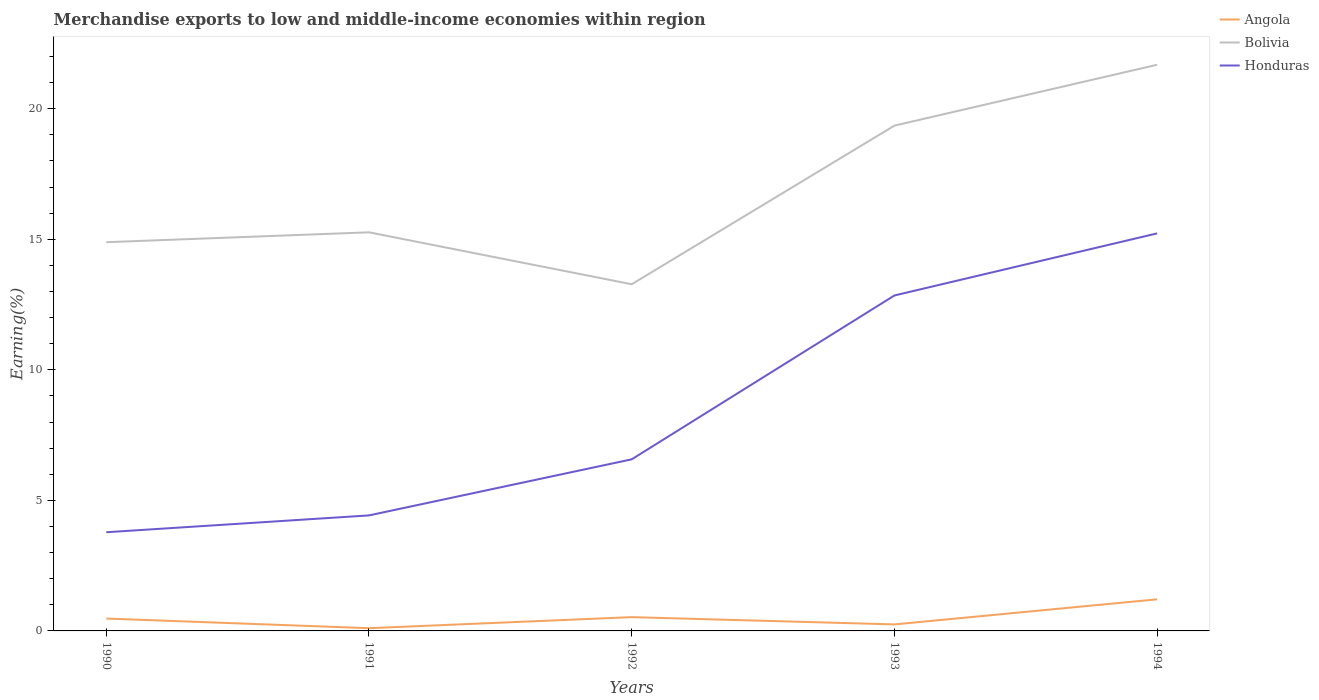Across all years, what is the maximum percentage of amount earned from merchandise exports in Honduras?
Provide a succinct answer. 3.78. In which year was the percentage of amount earned from merchandise exports in Honduras maximum?
Your answer should be compact. 1990. What is the total percentage of amount earned from merchandise exports in Angola in the graph?
Give a very brief answer. -0.14. What is the difference between the highest and the second highest percentage of amount earned from merchandise exports in Angola?
Ensure brevity in your answer.  1.11. What is the difference between the highest and the lowest percentage of amount earned from merchandise exports in Angola?
Make the answer very short. 2. How many lines are there?
Offer a very short reply. 3. Are the values on the major ticks of Y-axis written in scientific E-notation?
Ensure brevity in your answer.  No. Where does the legend appear in the graph?
Provide a short and direct response. Top right. What is the title of the graph?
Your answer should be compact. Merchandise exports to low and middle-income economies within region. What is the label or title of the X-axis?
Your answer should be compact. Years. What is the label or title of the Y-axis?
Keep it short and to the point. Earning(%). What is the Earning(%) in Angola in 1990?
Your answer should be very brief. 0.47. What is the Earning(%) in Bolivia in 1990?
Offer a very short reply. 14.89. What is the Earning(%) of Honduras in 1990?
Your answer should be compact. 3.78. What is the Earning(%) in Angola in 1991?
Your answer should be very brief. 0.1. What is the Earning(%) in Bolivia in 1991?
Your answer should be compact. 15.26. What is the Earning(%) in Honduras in 1991?
Provide a short and direct response. 4.42. What is the Earning(%) of Angola in 1992?
Give a very brief answer. 0.53. What is the Earning(%) in Bolivia in 1992?
Make the answer very short. 13.28. What is the Earning(%) of Honduras in 1992?
Keep it short and to the point. 6.57. What is the Earning(%) in Angola in 1993?
Your answer should be compact. 0.25. What is the Earning(%) of Bolivia in 1993?
Keep it short and to the point. 19.35. What is the Earning(%) in Honduras in 1993?
Your answer should be compact. 12.85. What is the Earning(%) of Angola in 1994?
Keep it short and to the point. 1.21. What is the Earning(%) in Bolivia in 1994?
Make the answer very short. 21.68. What is the Earning(%) in Honduras in 1994?
Ensure brevity in your answer.  15.22. Across all years, what is the maximum Earning(%) in Angola?
Make the answer very short. 1.21. Across all years, what is the maximum Earning(%) of Bolivia?
Your answer should be compact. 21.68. Across all years, what is the maximum Earning(%) in Honduras?
Your answer should be compact. 15.22. Across all years, what is the minimum Earning(%) of Angola?
Give a very brief answer. 0.1. Across all years, what is the minimum Earning(%) in Bolivia?
Keep it short and to the point. 13.28. Across all years, what is the minimum Earning(%) of Honduras?
Ensure brevity in your answer.  3.78. What is the total Earning(%) of Angola in the graph?
Give a very brief answer. 2.57. What is the total Earning(%) in Bolivia in the graph?
Ensure brevity in your answer.  84.46. What is the total Earning(%) in Honduras in the graph?
Give a very brief answer. 42.84. What is the difference between the Earning(%) in Angola in 1990 and that in 1991?
Give a very brief answer. 0.37. What is the difference between the Earning(%) in Bolivia in 1990 and that in 1991?
Offer a very short reply. -0.38. What is the difference between the Earning(%) of Honduras in 1990 and that in 1991?
Give a very brief answer. -0.64. What is the difference between the Earning(%) of Angola in 1990 and that in 1992?
Provide a short and direct response. -0.05. What is the difference between the Earning(%) in Bolivia in 1990 and that in 1992?
Make the answer very short. 1.61. What is the difference between the Earning(%) of Honduras in 1990 and that in 1992?
Give a very brief answer. -2.79. What is the difference between the Earning(%) in Angola in 1990 and that in 1993?
Your answer should be very brief. 0.22. What is the difference between the Earning(%) of Bolivia in 1990 and that in 1993?
Offer a terse response. -4.46. What is the difference between the Earning(%) of Honduras in 1990 and that in 1993?
Provide a succinct answer. -9.07. What is the difference between the Earning(%) of Angola in 1990 and that in 1994?
Offer a very short reply. -0.74. What is the difference between the Earning(%) of Bolivia in 1990 and that in 1994?
Make the answer very short. -6.8. What is the difference between the Earning(%) of Honduras in 1990 and that in 1994?
Offer a terse response. -11.45. What is the difference between the Earning(%) in Angola in 1991 and that in 1992?
Your answer should be compact. -0.42. What is the difference between the Earning(%) of Bolivia in 1991 and that in 1992?
Ensure brevity in your answer.  1.99. What is the difference between the Earning(%) in Honduras in 1991 and that in 1992?
Provide a succinct answer. -2.15. What is the difference between the Earning(%) in Angola in 1991 and that in 1993?
Provide a succinct answer. -0.14. What is the difference between the Earning(%) of Bolivia in 1991 and that in 1993?
Keep it short and to the point. -4.09. What is the difference between the Earning(%) in Honduras in 1991 and that in 1993?
Offer a terse response. -8.42. What is the difference between the Earning(%) of Angola in 1991 and that in 1994?
Your answer should be very brief. -1.11. What is the difference between the Earning(%) of Bolivia in 1991 and that in 1994?
Your answer should be compact. -6.42. What is the difference between the Earning(%) in Honduras in 1991 and that in 1994?
Your answer should be compact. -10.8. What is the difference between the Earning(%) of Angola in 1992 and that in 1993?
Keep it short and to the point. 0.28. What is the difference between the Earning(%) in Bolivia in 1992 and that in 1993?
Keep it short and to the point. -6.07. What is the difference between the Earning(%) of Honduras in 1992 and that in 1993?
Offer a very short reply. -6.28. What is the difference between the Earning(%) in Angola in 1992 and that in 1994?
Keep it short and to the point. -0.68. What is the difference between the Earning(%) of Bolivia in 1992 and that in 1994?
Your answer should be compact. -8.41. What is the difference between the Earning(%) of Honduras in 1992 and that in 1994?
Give a very brief answer. -8.65. What is the difference between the Earning(%) in Angola in 1993 and that in 1994?
Keep it short and to the point. -0.96. What is the difference between the Earning(%) of Bolivia in 1993 and that in 1994?
Offer a very short reply. -2.33. What is the difference between the Earning(%) of Honduras in 1993 and that in 1994?
Ensure brevity in your answer.  -2.38. What is the difference between the Earning(%) in Angola in 1990 and the Earning(%) in Bolivia in 1991?
Keep it short and to the point. -14.79. What is the difference between the Earning(%) in Angola in 1990 and the Earning(%) in Honduras in 1991?
Ensure brevity in your answer.  -3.95. What is the difference between the Earning(%) in Bolivia in 1990 and the Earning(%) in Honduras in 1991?
Make the answer very short. 10.46. What is the difference between the Earning(%) in Angola in 1990 and the Earning(%) in Bolivia in 1992?
Give a very brief answer. -12.8. What is the difference between the Earning(%) in Angola in 1990 and the Earning(%) in Honduras in 1992?
Give a very brief answer. -6.1. What is the difference between the Earning(%) of Bolivia in 1990 and the Earning(%) of Honduras in 1992?
Your response must be concise. 8.32. What is the difference between the Earning(%) in Angola in 1990 and the Earning(%) in Bolivia in 1993?
Give a very brief answer. -18.88. What is the difference between the Earning(%) of Angola in 1990 and the Earning(%) of Honduras in 1993?
Offer a very short reply. -12.37. What is the difference between the Earning(%) of Bolivia in 1990 and the Earning(%) of Honduras in 1993?
Your response must be concise. 2.04. What is the difference between the Earning(%) in Angola in 1990 and the Earning(%) in Bolivia in 1994?
Your answer should be very brief. -21.21. What is the difference between the Earning(%) in Angola in 1990 and the Earning(%) in Honduras in 1994?
Your answer should be compact. -14.75. What is the difference between the Earning(%) in Bolivia in 1990 and the Earning(%) in Honduras in 1994?
Your answer should be very brief. -0.34. What is the difference between the Earning(%) in Angola in 1991 and the Earning(%) in Bolivia in 1992?
Offer a very short reply. -13.17. What is the difference between the Earning(%) in Angola in 1991 and the Earning(%) in Honduras in 1992?
Your answer should be very brief. -6.47. What is the difference between the Earning(%) in Bolivia in 1991 and the Earning(%) in Honduras in 1992?
Your response must be concise. 8.69. What is the difference between the Earning(%) of Angola in 1991 and the Earning(%) of Bolivia in 1993?
Your answer should be very brief. -19.25. What is the difference between the Earning(%) of Angola in 1991 and the Earning(%) of Honduras in 1993?
Offer a terse response. -12.74. What is the difference between the Earning(%) of Bolivia in 1991 and the Earning(%) of Honduras in 1993?
Your answer should be compact. 2.42. What is the difference between the Earning(%) in Angola in 1991 and the Earning(%) in Bolivia in 1994?
Provide a short and direct response. -21.58. What is the difference between the Earning(%) of Angola in 1991 and the Earning(%) of Honduras in 1994?
Provide a short and direct response. -15.12. What is the difference between the Earning(%) in Bolivia in 1991 and the Earning(%) in Honduras in 1994?
Provide a succinct answer. 0.04. What is the difference between the Earning(%) in Angola in 1992 and the Earning(%) in Bolivia in 1993?
Ensure brevity in your answer.  -18.82. What is the difference between the Earning(%) of Angola in 1992 and the Earning(%) of Honduras in 1993?
Offer a very short reply. -12.32. What is the difference between the Earning(%) in Bolivia in 1992 and the Earning(%) in Honduras in 1993?
Keep it short and to the point. 0.43. What is the difference between the Earning(%) of Angola in 1992 and the Earning(%) of Bolivia in 1994?
Ensure brevity in your answer.  -21.15. What is the difference between the Earning(%) in Angola in 1992 and the Earning(%) in Honduras in 1994?
Offer a terse response. -14.7. What is the difference between the Earning(%) of Bolivia in 1992 and the Earning(%) of Honduras in 1994?
Your response must be concise. -1.95. What is the difference between the Earning(%) in Angola in 1993 and the Earning(%) in Bolivia in 1994?
Make the answer very short. -21.43. What is the difference between the Earning(%) of Angola in 1993 and the Earning(%) of Honduras in 1994?
Your answer should be very brief. -14.98. What is the difference between the Earning(%) in Bolivia in 1993 and the Earning(%) in Honduras in 1994?
Ensure brevity in your answer.  4.13. What is the average Earning(%) of Angola per year?
Your answer should be very brief. 0.51. What is the average Earning(%) of Bolivia per year?
Your answer should be compact. 16.89. What is the average Earning(%) of Honduras per year?
Provide a short and direct response. 8.57. In the year 1990, what is the difference between the Earning(%) in Angola and Earning(%) in Bolivia?
Give a very brief answer. -14.41. In the year 1990, what is the difference between the Earning(%) in Angola and Earning(%) in Honduras?
Keep it short and to the point. -3.31. In the year 1990, what is the difference between the Earning(%) of Bolivia and Earning(%) of Honduras?
Provide a succinct answer. 11.11. In the year 1991, what is the difference between the Earning(%) of Angola and Earning(%) of Bolivia?
Your response must be concise. -15.16. In the year 1991, what is the difference between the Earning(%) of Angola and Earning(%) of Honduras?
Give a very brief answer. -4.32. In the year 1991, what is the difference between the Earning(%) of Bolivia and Earning(%) of Honduras?
Your answer should be compact. 10.84. In the year 1992, what is the difference between the Earning(%) in Angola and Earning(%) in Bolivia?
Provide a succinct answer. -12.75. In the year 1992, what is the difference between the Earning(%) in Angola and Earning(%) in Honduras?
Give a very brief answer. -6.04. In the year 1992, what is the difference between the Earning(%) in Bolivia and Earning(%) in Honduras?
Offer a terse response. 6.7. In the year 1993, what is the difference between the Earning(%) of Angola and Earning(%) of Bolivia?
Give a very brief answer. -19.1. In the year 1993, what is the difference between the Earning(%) in Angola and Earning(%) in Honduras?
Make the answer very short. -12.6. In the year 1993, what is the difference between the Earning(%) in Bolivia and Earning(%) in Honduras?
Keep it short and to the point. 6.5. In the year 1994, what is the difference between the Earning(%) in Angola and Earning(%) in Bolivia?
Your response must be concise. -20.47. In the year 1994, what is the difference between the Earning(%) of Angola and Earning(%) of Honduras?
Ensure brevity in your answer.  -14.01. In the year 1994, what is the difference between the Earning(%) in Bolivia and Earning(%) in Honduras?
Your response must be concise. 6.46. What is the ratio of the Earning(%) in Angola in 1990 to that in 1991?
Offer a very short reply. 4.52. What is the ratio of the Earning(%) of Bolivia in 1990 to that in 1991?
Ensure brevity in your answer.  0.98. What is the ratio of the Earning(%) in Honduras in 1990 to that in 1991?
Your response must be concise. 0.85. What is the ratio of the Earning(%) of Angola in 1990 to that in 1992?
Your answer should be very brief. 0.9. What is the ratio of the Earning(%) in Bolivia in 1990 to that in 1992?
Provide a succinct answer. 1.12. What is the ratio of the Earning(%) in Honduras in 1990 to that in 1992?
Provide a succinct answer. 0.58. What is the ratio of the Earning(%) in Angola in 1990 to that in 1993?
Ensure brevity in your answer.  1.9. What is the ratio of the Earning(%) of Bolivia in 1990 to that in 1993?
Your answer should be very brief. 0.77. What is the ratio of the Earning(%) of Honduras in 1990 to that in 1993?
Your response must be concise. 0.29. What is the ratio of the Earning(%) of Angola in 1990 to that in 1994?
Your response must be concise. 0.39. What is the ratio of the Earning(%) in Bolivia in 1990 to that in 1994?
Ensure brevity in your answer.  0.69. What is the ratio of the Earning(%) of Honduras in 1990 to that in 1994?
Keep it short and to the point. 0.25. What is the ratio of the Earning(%) in Angola in 1991 to that in 1992?
Give a very brief answer. 0.2. What is the ratio of the Earning(%) of Bolivia in 1991 to that in 1992?
Offer a terse response. 1.15. What is the ratio of the Earning(%) of Honduras in 1991 to that in 1992?
Your response must be concise. 0.67. What is the ratio of the Earning(%) of Angola in 1991 to that in 1993?
Your answer should be compact. 0.42. What is the ratio of the Earning(%) of Bolivia in 1991 to that in 1993?
Make the answer very short. 0.79. What is the ratio of the Earning(%) of Honduras in 1991 to that in 1993?
Provide a succinct answer. 0.34. What is the ratio of the Earning(%) in Angola in 1991 to that in 1994?
Your response must be concise. 0.09. What is the ratio of the Earning(%) in Bolivia in 1991 to that in 1994?
Your response must be concise. 0.7. What is the ratio of the Earning(%) of Honduras in 1991 to that in 1994?
Offer a very short reply. 0.29. What is the ratio of the Earning(%) of Angola in 1992 to that in 1993?
Ensure brevity in your answer.  2.11. What is the ratio of the Earning(%) in Bolivia in 1992 to that in 1993?
Your answer should be very brief. 0.69. What is the ratio of the Earning(%) in Honduras in 1992 to that in 1993?
Your answer should be very brief. 0.51. What is the ratio of the Earning(%) of Angola in 1992 to that in 1994?
Give a very brief answer. 0.44. What is the ratio of the Earning(%) in Bolivia in 1992 to that in 1994?
Your response must be concise. 0.61. What is the ratio of the Earning(%) of Honduras in 1992 to that in 1994?
Offer a terse response. 0.43. What is the ratio of the Earning(%) of Angola in 1993 to that in 1994?
Your answer should be very brief. 0.21. What is the ratio of the Earning(%) in Bolivia in 1993 to that in 1994?
Your response must be concise. 0.89. What is the ratio of the Earning(%) of Honduras in 1993 to that in 1994?
Make the answer very short. 0.84. What is the difference between the highest and the second highest Earning(%) in Angola?
Your answer should be very brief. 0.68. What is the difference between the highest and the second highest Earning(%) in Bolivia?
Your response must be concise. 2.33. What is the difference between the highest and the second highest Earning(%) of Honduras?
Give a very brief answer. 2.38. What is the difference between the highest and the lowest Earning(%) in Angola?
Your answer should be compact. 1.11. What is the difference between the highest and the lowest Earning(%) of Bolivia?
Your response must be concise. 8.41. What is the difference between the highest and the lowest Earning(%) in Honduras?
Offer a terse response. 11.45. 